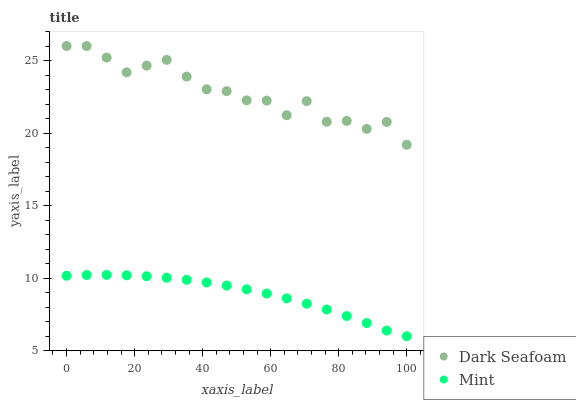Does Mint have the minimum area under the curve?
Answer yes or no. Yes. Does Dark Seafoam have the maximum area under the curve?
Answer yes or no. Yes. Does Mint have the maximum area under the curve?
Answer yes or no. No. Is Mint the smoothest?
Answer yes or no. Yes. Is Dark Seafoam the roughest?
Answer yes or no. Yes. Is Mint the roughest?
Answer yes or no. No. Does Mint have the lowest value?
Answer yes or no. Yes. Does Dark Seafoam have the highest value?
Answer yes or no. Yes. Does Mint have the highest value?
Answer yes or no. No. Is Mint less than Dark Seafoam?
Answer yes or no. Yes. Is Dark Seafoam greater than Mint?
Answer yes or no. Yes. Does Mint intersect Dark Seafoam?
Answer yes or no. No. 